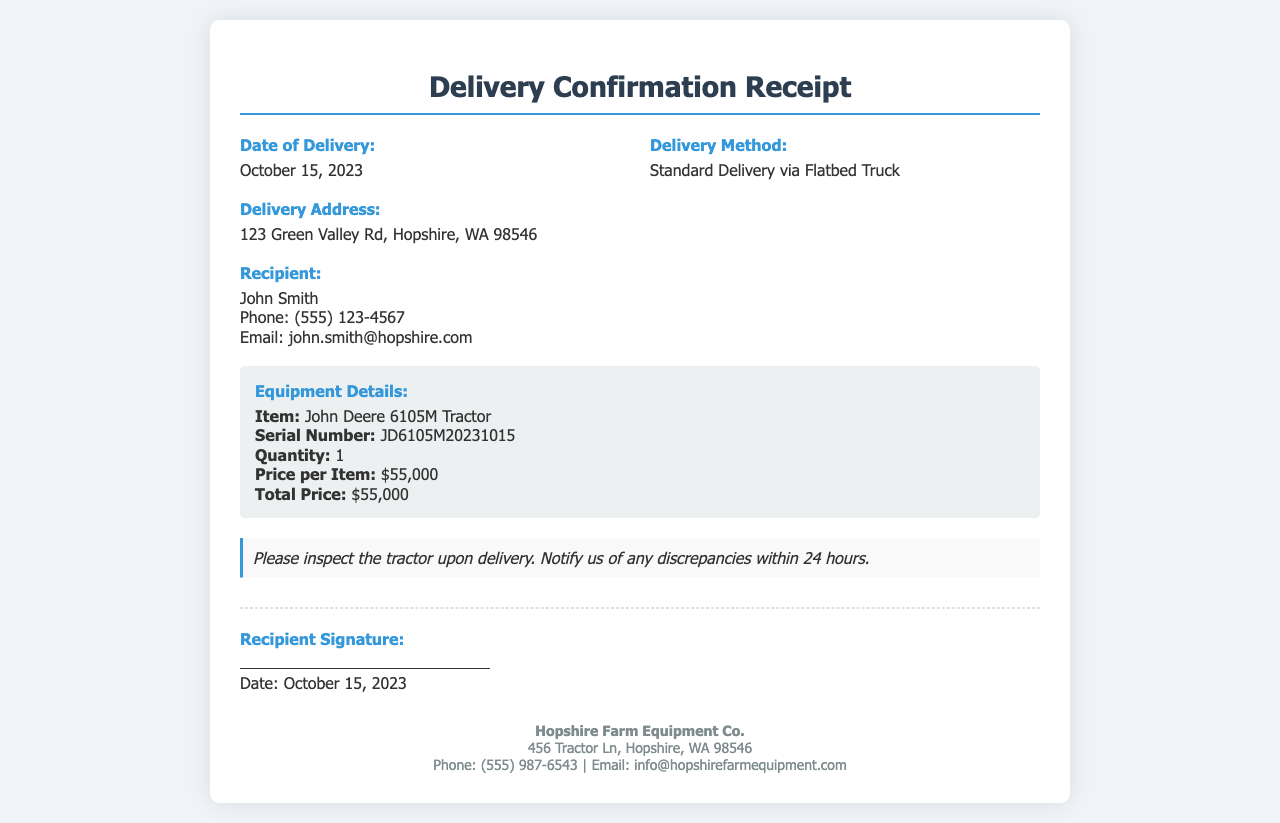What is the date of delivery? The delivery date can be found in the section labeled "Date of Delivery" in the document.
Answer: October 15, 2023 Who is the recipient? The recipient's name is stated in the section labeled "Recipient."
Answer: John Smith What is the delivery address? The delivery address is specified in the section labeled "Delivery Address."
Answer: 123 Green Valley Rd, Hopshire, WA 98546 What is the total price of the tractor? The total price is indicated in the "Equipment Details" section of the document.
Answer: $55,000 What is the phone number of the recipient? The recipient's phone number is mentioned in the recipient details section.
Answer: (555) 123-4567 What type of tractor was delivered? The type of tractor is described in the "Equipment Details" section, which lists the item.
Answer: John Deere 6105M Tractor What should be done if there are discrepancies upon delivery? The notes section advises on actions to take regarding discrepancies found.
Answer: Notify us within 24 hours What is the dealer's phone number? The dealer's contact information is provided at the bottom of the receipt, including their phone number.
Answer: (555) 987-6543 What is included in the delivery method? The delivery method is described in the "Delivery Method" section.
Answer: Standard Delivery via Flatbed Truck 